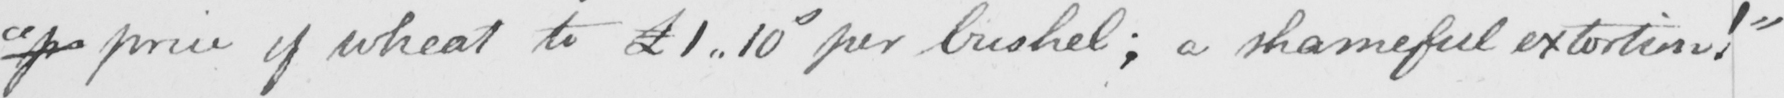Can you tell me what this handwritten text says? " p price of wheat £1..10s per bushel ; a shameful extortion !  " 